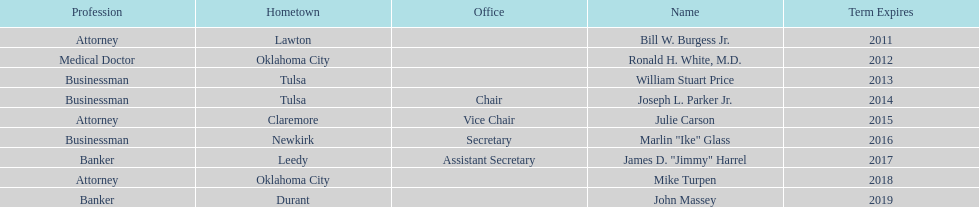How many of the current state regents have a listed office title? 4. 